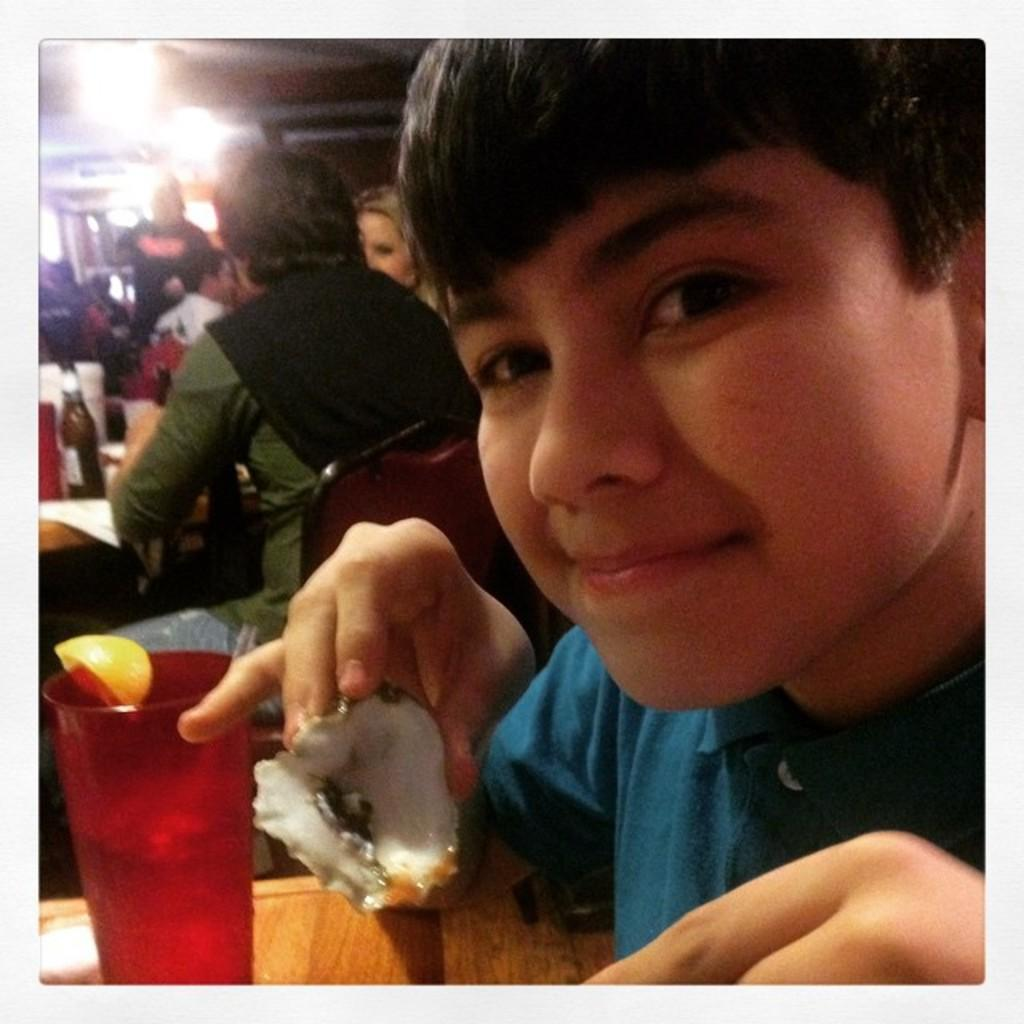Who is the main subject in the image? There is a boy in the image. What is the boy holding in the image? The boy is holding an oyster. What other objects can be seen in the image? There is a glass, papers, and bottles on the table. Can you describe the background of the image? There is a group of people sitting in the background and a person standing in the background. What type of popcorn is being served to the government in the image? There is no popcorn or government present in the image. What form is the boy holding in the image? The boy is holding an oyster, not a form. 